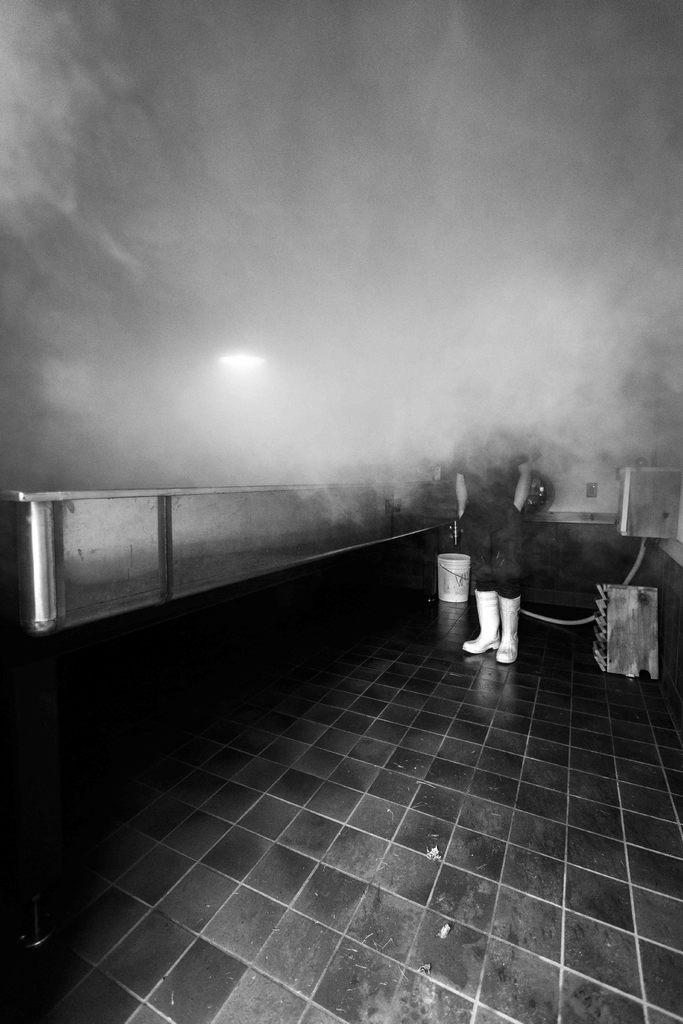What is the main subject in the image? There is a person standing in the image. What else can be seen on the floor in the image? There are objects on the floor in the image. How would you describe the color scheme of the image? The image is black and white in color. How many cows can be seen grazing in the wilderness in the image? There are no cows or wilderness present in the image; it features a person standing and objects on the floor in a black and white setting. 